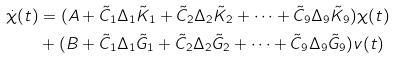Convert formula to latex. <formula><loc_0><loc_0><loc_500><loc_500>\dot { \chi } ( t ) & = ( A + \tilde { C } _ { 1 } \Delta _ { 1 } \tilde { K } _ { 1 } + \tilde { C } _ { 2 } \Delta _ { 2 } \tilde { K } _ { 2 } + \cdots + \tilde { C } _ { 9 } \Delta _ { 9 } \tilde { K } _ { 9 } ) \chi ( t ) \\ & + ( B + \tilde { C } _ { 1 } \Delta _ { 1 } \tilde { G } _ { 1 } + \tilde { C } _ { 2 } \Delta _ { 2 } \tilde { G } _ { 2 } + \cdots + \tilde { C } _ { 9 } \Delta _ { 9 } \tilde { G } _ { 9 } ) v ( t )</formula> 